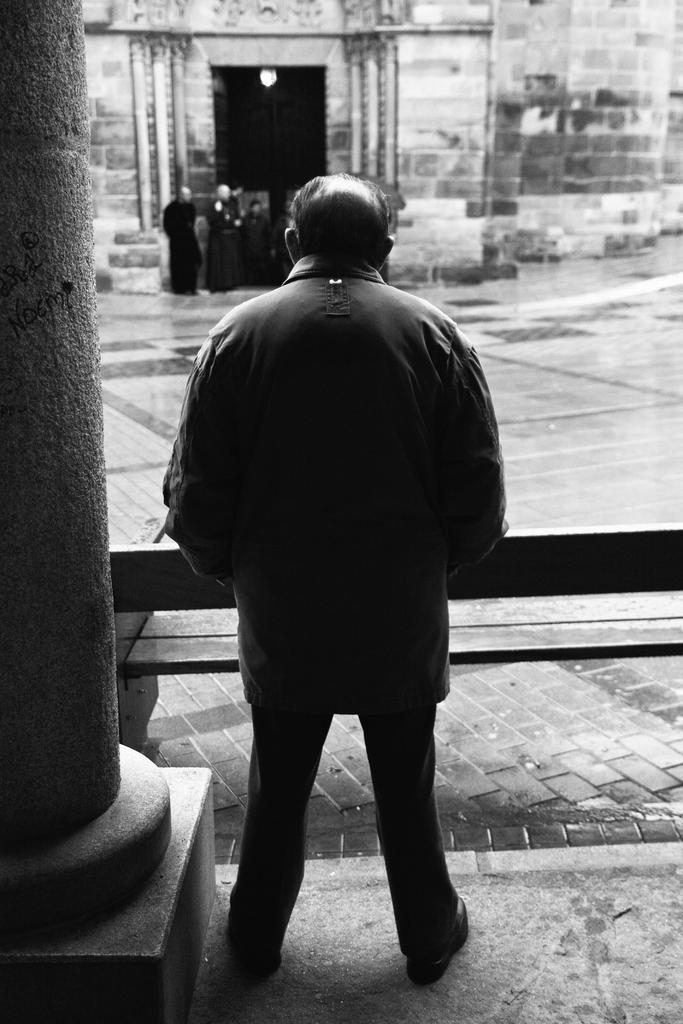What is the main subject of the image? There is a man standing in the image. Are there any other people visible in the image? Yes, there are people standing in the background of the image. What can be seen in the distance behind the man? There appears to be a building in the background of the image. What architectural feature is present on the left side of the image? There is a pillar on the left side of the image. What type of birds are flying around the man's head in the image? There are no birds visible in the image. What kind of approval is the man seeking in the image? The image does not depict the man seeking any approval; it simply shows him standing with other people and a building in the background. 